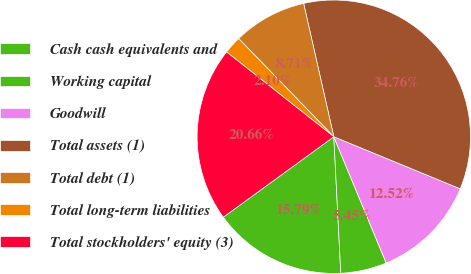Convert chart to OTSL. <chart><loc_0><loc_0><loc_500><loc_500><pie_chart><fcel>Cash cash equivalents and<fcel>Working capital<fcel>Goodwill<fcel>Total assets (1)<fcel>Total debt (1)<fcel>Total long-term liabilities<fcel>Total stockholders' equity (3)<nl><fcel>15.79%<fcel>5.45%<fcel>12.52%<fcel>34.76%<fcel>8.71%<fcel>2.1%<fcel>20.66%<nl></chart> 